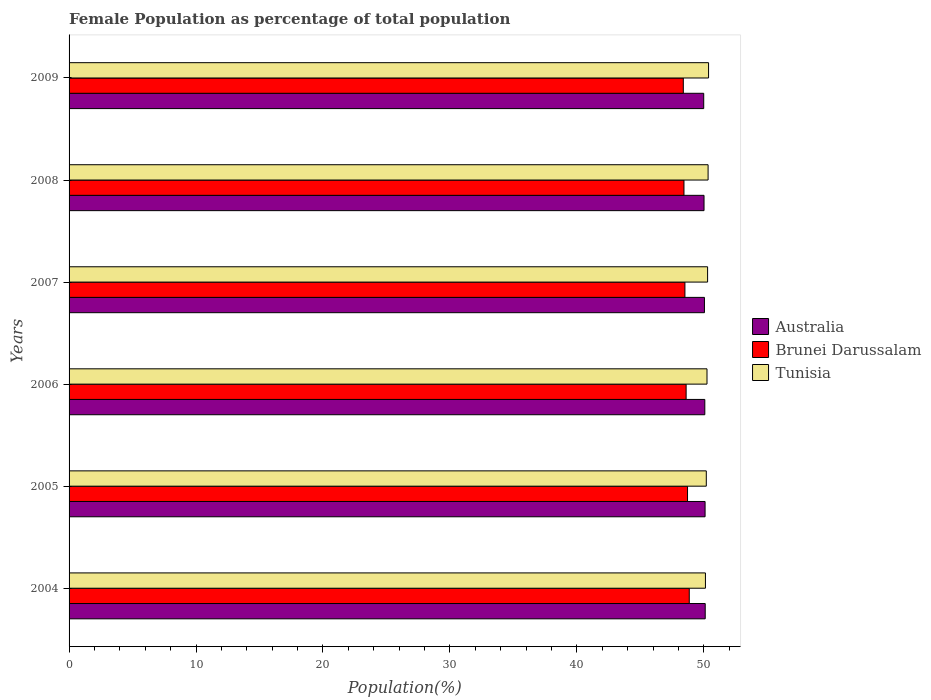How many different coloured bars are there?
Offer a terse response. 3. How many groups of bars are there?
Your response must be concise. 6. Are the number of bars per tick equal to the number of legend labels?
Give a very brief answer. Yes. Are the number of bars on each tick of the Y-axis equal?
Your answer should be very brief. Yes. How many bars are there on the 3rd tick from the top?
Provide a short and direct response. 3. How many bars are there on the 3rd tick from the bottom?
Keep it short and to the point. 3. What is the label of the 4th group of bars from the top?
Your answer should be compact. 2006. What is the female population in in Tunisia in 2007?
Provide a succinct answer. 50.3. Across all years, what is the maximum female population in in Australia?
Make the answer very short. 50.11. Across all years, what is the minimum female population in in Tunisia?
Make the answer very short. 50.13. What is the total female population in in Brunei Darussalam in the graph?
Make the answer very short. 291.51. What is the difference between the female population in in Tunisia in 2007 and that in 2009?
Make the answer very short. -0.08. What is the difference between the female population in in Brunei Darussalam in 2004 and the female population in in Tunisia in 2009?
Make the answer very short. -1.52. What is the average female population in in Australia per year?
Make the answer very short. 50.06. In the year 2007, what is the difference between the female population in in Tunisia and female population in in Australia?
Provide a succinct answer. 0.25. What is the ratio of the female population in in Tunisia in 2007 to that in 2008?
Keep it short and to the point. 1. What is the difference between the highest and the second highest female population in in Brunei Darussalam?
Offer a terse response. 0.14. What is the difference between the highest and the lowest female population in in Australia?
Your answer should be compact. 0.12. What does the 1st bar from the top in 2004 represents?
Give a very brief answer. Tunisia. What does the 3rd bar from the bottom in 2008 represents?
Your answer should be very brief. Tunisia. Is it the case that in every year, the sum of the female population in in Tunisia and female population in in Brunei Darussalam is greater than the female population in in Australia?
Keep it short and to the point. Yes. How many bars are there?
Provide a short and direct response. 18. How many years are there in the graph?
Keep it short and to the point. 6. Does the graph contain any zero values?
Make the answer very short. No. How many legend labels are there?
Make the answer very short. 3. How are the legend labels stacked?
Keep it short and to the point. Vertical. What is the title of the graph?
Your answer should be very brief. Female Population as percentage of total population. What is the label or title of the X-axis?
Provide a short and direct response. Population(%). What is the Population(%) of Australia in 2004?
Provide a short and direct response. 50.11. What is the Population(%) of Brunei Darussalam in 2004?
Your answer should be compact. 48.85. What is the Population(%) in Tunisia in 2004?
Ensure brevity in your answer.  50.13. What is the Population(%) in Australia in 2005?
Give a very brief answer. 50.1. What is the Population(%) in Brunei Darussalam in 2005?
Provide a succinct answer. 48.72. What is the Population(%) of Tunisia in 2005?
Offer a terse response. 50.2. What is the Population(%) of Australia in 2006?
Provide a succinct answer. 50.08. What is the Population(%) of Brunei Darussalam in 2006?
Give a very brief answer. 48.61. What is the Population(%) in Tunisia in 2006?
Provide a short and direct response. 50.25. What is the Population(%) of Australia in 2007?
Make the answer very short. 50.05. What is the Population(%) of Brunei Darussalam in 2007?
Your answer should be compact. 48.51. What is the Population(%) of Tunisia in 2007?
Provide a succinct answer. 50.3. What is the Population(%) in Australia in 2008?
Provide a succinct answer. 50.02. What is the Population(%) of Brunei Darussalam in 2008?
Your answer should be compact. 48.44. What is the Population(%) of Tunisia in 2008?
Provide a short and direct response. 50.34. What is the Population(%) of Australia in 2009?
Make the answer very short. 49.99. What is the Population(%) in Brunei Darussalam in 2009?
Make the answer very short. 48.38. What is the Population(%) of Tunisia in 2009?
Your response must be concise. 50.37. Across all years, what is the maximum Population(%) of Australia?
Offer a terse response. 50.11. Across all years, what is the maximum Population(%) in Brunei Darussalam?
Offer a terse response. 48.85. Across all years, what is the maximum Population(%) of Tunisia?
Offer a terse response. 50.37. Across all years, what is the minimum Population(%) in Australia?
Keep it short and to the point. 49.99. Across all years, what is the minimum Population(%) of Brunei Darussalam?
Provide a short and direct response. 48.38. Across all years, what is the minimum Population(%) in Tunisia?
Keep it short and to the point. 50.13. What is the total Population(%) in Australia in the graph?
Offer a terse response. 300.35. What is the total Population(%) in Brunei Darussalam in the graph?
Keep it short and to the point. 291.51. What is the total Population(%) of Tunisia in the graph?
Your answer should be compact. 301.58. What is the difference between the Population(%) in Australia in 2004 and that in 2005?
Offer a very short reply. 0.01. What is the difference between the Population(%) in Brunei Darussalam in 2004 and that in 2005?
Offer a terse response. 0.14. What is the difference between the Population(%) of Tunisia in 2004 and that in 2005?
Your response must be concise. -0.07. What is the difference between the Population(%) in Australia in 2004 and that in 2006?
Give a very brief answer. 0.03. What is the difference between the Population(%) in Brunei Darussalam in 2004 and that in 2006?
Your answer should be very brief. 0.25. What is the difference between the Population(%) in Tunisia in 2004 and that in 2006?
Keep it short and to the point. -0.12. What is the difference between the Population(%) in Australia in 2004 and that in 2007?
Your answer should be very brief. 0.06. What is the difference between the Population(%) of Brunei Darussalam in 2004 and that in 2007?
Your answer should be compact. 0.34. What is the difference between the Population(%) in Tunisia in 2004 and that in 2007?
Make the answer very short. -0.17. What is the difference between the Population(%) of Australia in 2004 and that in 2008?
Ensure brevity in your answer.  0.09. What is the difference between the Population(%) in Brunei Darussalam in 2004 and that in 2008?
Your answer should be very brief. 0.42. What is the difference between the Population(%) in Tunisia in 2004 and that in 2008?
Provide a short and direct response. -0.21. What is the difference between the Population(%) in Australia in 2004 and that in 2009?
Ensure brevity in your answer.  0.12. What is the difference between the Population(%) of Brunei Darussalam in 2004 and that in 2009?
Give a very brief answer. 0.47. What is the difference between the Population(%) in Tunisia in 2004 and that in 2009?
Your answer should be compact. -0.25. What is the difference between the Population(%) of Australia in 2005 and that in 2006?
Give a very brief answer. 0.02. What is the difference between the Population(%) of Brunei Darussalam in 2005 and that in 2006?
Keep it short and to the point. 0.11. What is the difference between the Population(%) in Tunisia in 2005 and that in 2006?
Provide a short and direct response. -0.06. What is the difference between the Population(%) of Australia in 2005 and that in 2007?
Your answer should be compact. 0.05. What is the difference between the Population(%) in Brunei Darussalam in 2005 and that in 2007?
Make the answer very short. 0.21. What is the difference between the Population(%) in Tunisia in 2005 and that in 2007?
Provide a short and direct response. -0.1. What is the difference between the Population(%) in Australia in 2005 and that in 2008?
Keep it short and to the point. 0.08. What is the difference between the Population(%) in Brunei Darussalam in 2005 and that in 2008?
Provide a succinct answer. 0.28. What is the difference between the Population(%) in Tunisia in 2005 and that in 2008?
Ensure brevity in your answer.  -0.14. What is the difference between the Population(%) of Australia in 2005 and that in 2009?
Provide a succinct answer. 0.11. What is the difference between the Population(%) in Brunei Darussalam in 2005 and that in 2009?
Your answer should be very brief. 0.33. What is the difference between the Population(%) in Tunisia in 2005 and that in 2009?
Give a very brief answer. -0.18. What is the difference between the Population(%) in Australia in 2006 and that in 2007?
Ensure brevity in your answer.  0.03. What is the difference between the Population(%) in Brunei Darussalam in 2006 and that in 2007?
Keep it short and to the point. 0.1. What is the difference between the Population(%) in Tunisia in 2006 and that in 2007?
Provide a succinct answer. -0.05. What is the difference between the Population(%) of Australia in 2006 and that in 2008?
Make the answer very short. 0.06. What is the difference between the Population(%) of Brunei Darussalam in 2006 and that in 2008?
Offer a very short reply. 0.17. What is the difference between the Population(%) of Tunisia in 2006 and that in 2008?
Your answer should be compact. -0.09. What is the difference between the Population(%) of Australia in 2006 and that in 2009?
Your answer should be very brief. 0.09. What is the difference between the Population(%) of Brunei Darussalam in 2006 and that in 2009?
Offer a terse response. 0.22. What is the difference between the Population(%) of Tunisia in 2006 and that in 2009?
Make the answer very short. -0.12. What is the difference between the Population(%) of Australia in 2007 and that in 2008?
Give a very brief answer. 0.03. What is the difference between the Population(%) in Brunei Darussalam in 2007 and that in 2008?
Keep it short and to the point. 0.07. What is the difference between the Population(%) in Tunisia in 2007 and that in 2008?
Provide a short and direct response. -0.04. What is the difference between the Population(%) in Australia in 2007 and that in 2009?
Make the answer very short. 0.06. What is the difference between the Population(%) in Brunei Darussalam in 2007 and that in 2009?
Keep it short and to the point. 0.13. What is the difference between the Population(%) in Tunisia in 2007 and that in 2009?
Ensure brevity in your answer.  -0.08. What is the difference between the Population(%) in Australia in 2008 and that in 2009?
Offer a terse response. 0.02. What is the difference between the Population(%) of Brunei Darussalam in 2008 and that in 2009?
Keep it short and to the point. 0.05. What is the difference between the Population(%) of Tunisia in 2008 and that in 2009?
Your answer should be compact. -0.04. What is the difference between the Population(%) in Australia in 2004 and the Population(%) in Brunei Darussalam in 2005?
Ensure brevity in your answer.  1.39. What is the difference between the Population(%) of Australia in 2004 and the Population(%) of Tunisia in 2005?
Keep it short and to the point. -0.08. What is the difference between the Population(%) in Brunei Darussalam in 2004 and the Population(%) in Tunisia in 2005?
Offer a very short reply. -1.34. What is the difference between the Population(%) in Australia in 2004 and the Population(%) in Brunei Darussalam in 2006?
Your answer should be very brief. 1.5. What is the difference between the Population(%) in Australia in 2004 and the Population(%) in Tunisia in 2006?
Keep it short and to the point. -0.14. What is the difference between the Population(%) of Brunei Darussalam in 2004 and the Population(%) of Tunisia in 2006?
Provide a short and direct response. -1.4. What is the difference between the Population(%) in Australia in 2004 and the Population(%) in Brunei Darussalam in 2007?
Your answer should be compact. 1.6. What is the difference between the Population(%) of Australia in 2004 and the Population(%) of Tunisia in 2007?
Your response must be concise. -0.19. What is the difference between the Population(%) in Brunei Darussalam in 2004 and the Population(%) in Tunisia in 2007?
Your answer should be very brief. -1.44. What is the difference between the Population(%) of Australia in 2004 and the Population(%) of Brunei Darussalam in 2008?
Offer a very short reply. 1.67. What is the difference between the Population(%) of Australia in 2004 and the Population(%) of Tunisia in 2008?
Give a very brief answer. -0.23. What is the difference between the Population(%) of Brunei Darussalam in 2004 and the Population(%) of Tunisia in 2008?
Ensure brevity in your answer.  -1.48. What is the difference between the Population(%) of Australia in 2004 and the Population(%) of Brunei Darussalam in 2009?
Keep it short and to the point. 1.73. What is the difference between the Population(%) in Australia in 2004 and the Population(%) in Tunisia in 2009?
Offer a terse response. -0.26. What is the difference between the Population(%) in Brunei Darussalam in 2004 and the Population(%) in Tunisia in 2009?
Keep it short and to the point. -1.52. What is the difference between the Population(%) in Australia in 2005 and the Population(%) in Brunei Darussalam in 2006?
Provide a short and direct response. 1.49. What is the difference between the Population(%) of Australia in 2005 and the Population(%) of Tunisia in 2006?
Make the answer very short. -0.15. What is the difference between the Population(%) of Brunei Darussalam in 2005 and the Population(%) of Tunisia in 2006?
Your answer should be compact. -1.53. What is the difference between the Population(%) in Australia in 2005 and the Population(%) in Brunei Darussalam in 2007?
Offer a terse response. 1.59. What is the difference between the Population(%) of Australia in 2005 and the Population(%) of Tunisia in 2007?
Your response must be concise. -0.2. What is the difference between the Population(%) of Brunei Darussalam in 2005 and the Population(%) of Tunisia in 2007?
Your response must be concise. -1.58. What is the difference between the Population(%) of Australia in 2005 and the Population(%) of Brunei Darussalam in 2008?
Make the answer very short. 1.66. What is the difference between the Population(%) in Australia in 2005 and the Population(%) in Tunisia in 2008?
Your answer should be very brief. -0.24. What is the difference between the Population(%) of Brunei Darussalam in 2005 and the Population(%) of Tunisia in 2008?
Your answer should be very brief. -1.62. What is the difference between the Population(%) in Australia in 2005 and the Population(%) in Brunei Darussalam in 2009?
Provide a short and direct response. 1.72. What is the difference between the Population(%) of Australia in 2005 and the Population(%) of Tunisia in 2009?
Keep it short and to the point. -0.27. What is the difference between the Population(%) in Brunei Darussalam in 2005 and the Population(%) in Tunisia in 2009?
Your response must be concise. -1.66. What is the difference between the Population(%) of Australia in 2006 and the Population(%) of Brunei Darussalam in 2007?
Give a very brief answer. 1.57. What is the difference between the Population(%) in Australia in 2006 and the Population(%) in Tunisia in 2007?
Your response must be concise. -0.22. What is the difference between the Population(%) in Brunei Darussalam in 2006 and the Population(%) in Tunisia in 2007?
Give a very brief answer. -1.69. What is the difference between the Population(%) of Australia in 2006 and the Population(%) of Brunei Darussalam in 2008?
Offer a very short reply. 1.64. What is the difference between the Population(%) of Australia in 2006 and the Population(%) of Tunisia in 2008?
Provide a short and direct response. -0.26. What is the difference between the Population(%) of Brunei Darussalam in 2006 and the Population(%) of Tunisia in 2008?
Keep it short and to the point. -1.73. What is the difference between the Population(%) of Australia in 2006 and the Population(%) of Brunei Darussalam in 2009?
Provide a succinct answer. 1.69. What is the difference between the Population(%) of Australia in 2006 and the Population(%) of Tunisia in 2009?
Keep it short and to the point. -0.3. What is the difference between the Population(%) in Brunei Darussalam in 2006 and the Population(%) in Tunisia in 2009?
Provide a short and direct response. -1.77. What is the difference between the Population(%) in Australia in 2007 and the Population(%) in Brunei Darussalam in 2008?
Ensure brevity in your answer.  1.61. What is the difference between the Population(%) of Australia in 2007 and the Population(%) of Tunisia in 2008?
Your answer should be very brief. -0.29. What is the difference between the Population(%) of Brunei Darussalam in 2007 and the Population(%) of Tunisia in 2008?
Your answer should be compact. -1.83. What is the difference between the Population(%) in Australia in 2007 and the Population(%) in Brunei Darussalam in 2009?
Your response must be concise. 1.66. What is the difference between the Population(%) in Australia in 2007 and the Population(%) in Tunisia in 2009?
Provide a succinct answer. -0.33. What is the difference between the Population(%) in Brunei Darussalam in 2007 and the Population(%) in Tunisia in 2009?
Provide a succinct answer. -1.86. What is the difference between the Population(%) in Australia in 2008 and the Population(%) in Brunei Darussalam in 2009?
Ensure brevity in your answer.  1.63. What is the difference between the Population(%) in Australia in 2008 and the Population(%) in Tunisia in 2009?
Provide a short and direct response. -0.36. What is the difference between the Population(%) in Brunei Darussalam in 2008 and the Population(%) in Tunisia in 2009?
Keep it short and to the point. -1.94. What is the average Population(%) in Australia per year?
Offer a terse response. 50.06. What is the average Population(%) of Brunei Darussalam per year?
Your response must be concise. 48.59. What is the average Population(%) in Tunisia per year?
Ensure brevity in your answer.  50.26. In the year 2004, what is the difference between the Population(%) of Australia and Population(%) of Brunei Darussalam?
Offer a very short reply. 1.26. In the year 2004, what is the difference between the Population(%) of Australia and Population(%) of Tunisia?
Provide a succinct answer. -0.02. In the year 2004, what is the difference between the Population(%) of Brunei Darussalam and Population(%) of Tunisia?
Make the answer very short. -1.27. In the year 2005, what is the difference between the Population(%) of Australia and Population(%) of Brunei Darussalam?
Make the answer very short. 1.38. In the year 2005, what is the difference between the Population(%) of Australia and Population(%) of Tunisia?
Your response must be concise. -0.1. In the year 2005, what is the difference between the Population(%) in Brunei Darussalam and Population(%) in Tunisia?
Give a very brief answer. -1.48. In the year 2006, what is the difference between the Population(%) in Australia and Population(%) in Brunei Darussalam?
Offer a terse response. 1.47. In the year 2006, what is the difference between the Population(%) of Australia and Population(%) of Tunisia?
Ensure brevity in your answer.  -0.17. In the year 2006, what is the difference between the Population(%) in Brunei Darussalam and Population(%) in Tunisia?
Offer a very short reply. -1.64. In the year 2007, what is the difference between the Population(%) of Australia and Population(%) of Brunei Darussalam?
Ensure brevity in your answer.  1.54. In the year 2007, what is the difference between the Population(%) of Australia and Population(%) of Tunisia?
Provide a succinct answer. -0.25. In the year 2007, what is the difference between the Population(%) in Brunei Darussalam and Population(%) in Tunisia?
Ensure brevity in your answer.  -1.79. In the year 2008, what is the difference between the Population(%) of Australia and Population(%) of Brunei Darussalam?
Your response must be concise. 1.58. In the year 2008, what is the difference between the Population(%) in Australia and Population(%) in Tunisia?
Offer a terse response. -0.32. In the year 2008, what is the difference between the Population(%) of Brunei Darussalam and Population(%) of Tunisia?
Your response must be concise. -1.9. In the year 2009, what is the difference between the Population(%) of Australia and Population(%) of Brunei Darussalam?
Provide a short and direct response. 1.61. In the year 2009, what is the difference between the Population(%) in Australia and Population(%) in Tunisia?
Offer a very short reply. -0.38. In the year 2009, what is the difference between the Population(%) in Brunei Darussalam and Population(%) in Tunisia?
Your response must be concise. -1.99. What is the ratio of the Population(%) of Australia in 2004 to that in 2005?
Your answer should be compact. 1. What is the ratio of the Population(%) of Tunisia in 2004 to that in 2006?
Offer a very short reply. 1. What is the ratio of the Population(%) in Australia in 2004 to that in 2007?
Give a very brief answer. 1. What is the ratio of the Population(%) in Brunei Darussalam in 2004 to that in 2007?
Provide a succinct answer. 1.01. What is the ratio of the Population(%) in Tunisia in 2004 to that in 2007?
Provide a succinct answer. 1. What is the ratio of the Population(%) in Brunei Darussalam in 2004 to that in 2008?
Your answer should be compact. 1.01. What is the ratio of the Population(%) in Tunisia in 2004 to that in 2008?
Offer a very short reply. 1. What is the ratio of the Population(%) of Australia in 2004 to that in 2009?
Provide a short and direct response. 1. What is the ratio of the Population(%) of Brunei Darussalam in 2004 to that in 2009?
Keep it short and to the point. 1.01. What is the ratio of the Population(%) of Tunisia in 2004 to that in 2009?
Make the answer very short. 1. What is the ratio of the Population(%) in Australia in 2005 to that in 2006?
Your answer should be compact. 1. What is the ratio of the Population(%) of Brunei Darussalam in 2005 to that in 2007?
Offer a terse response. 1. What is the ratio of the Population(%) of Australia in 2005 to that in 2008?
Your response must be concise. 1. What is the ratio of the Population(%) in Brunei Darussalam in 2005 to that in 2008?
Your response must be concise. 1.01. What is the ratio of the Population(%) of Tunisia in 2005 to that in 2008?
Your answer should be very brief. 1. What is the ratio of the Population(%) in Australia in 2005 to that in 2009?
Ensure brevity in your answer.  1. What is the ratio of the Population(%) in Brunei Darussalam in 2005 to that in 2009?
Your response must be concise. 1.01. What is the ratio of the Population(%) of Australia in 2006 to that in 2007?
Give a very brief answer. 1. What is the ratio of the Population(%) in Australia in 2006 to that in 2008?
Your response must be concise. 1. What is the ratio of the Population(%) of Brunei Darussalam in 2006 to that in 2008?
Make the answer very short. 1. What is the ratio of the Population(%) in Brunei Darussalam in 2006 to that in 2009?
Give a very brief answer. 1. What is the ratio of the Population(%) of Tunisia in 2006 to that in 2009?
Provide a succinct answer. 1. What is the ratio of the Population(%) in Australia in 2007 to that in 2008?
Give a very brief answer. 1. What is the ratio of the Population(%) in Australia in 2007 to that in 2009?
Your answer should be compact. 1. What is the ratio of the Population(%) of Brunei Darussalam in 2007 to that in 2009?
Offer a terse response. 1. What is the ratio of the Population(%) in Tunisia in 2007 to that in 2009?
Ensure brevity in your answer.  1. What is the ratio of the Population(%) of Australia in 2008 to that in 2009?
Give a very brief answer. 1. What is the ratio of the Population(%) of Brunei Darussalam in 2008 to that in 2009?
Your answer should be compact. 1. What is the ratio of the Population(%) of Tunisia in 2008 to that in 2009?
Offer a very short reply. 1. What is the difference between the highest and the second highest Population(%) of Australia?
Provide a short and direct response. 0.01. What is the difference between the highest and the second highest Population(%) in Brunei Darussalam?
Give a very brief answer. 0.14. What is the difference between the highest and the second highest Population(%) of Tunisia?
Your answer should be compact. 0.04. What is the difference between the highest and the lowest Population(%) of Australia?
Keep it short and to the point. 0.12. What is the difference between the highest and the lowest Population(%) in Brunei Darussalam?
Your answer should be compact. 0.47. What is the difference between the highest and the lowest Population(%) of Tunisia?
Your response must be concise. 0.25. 